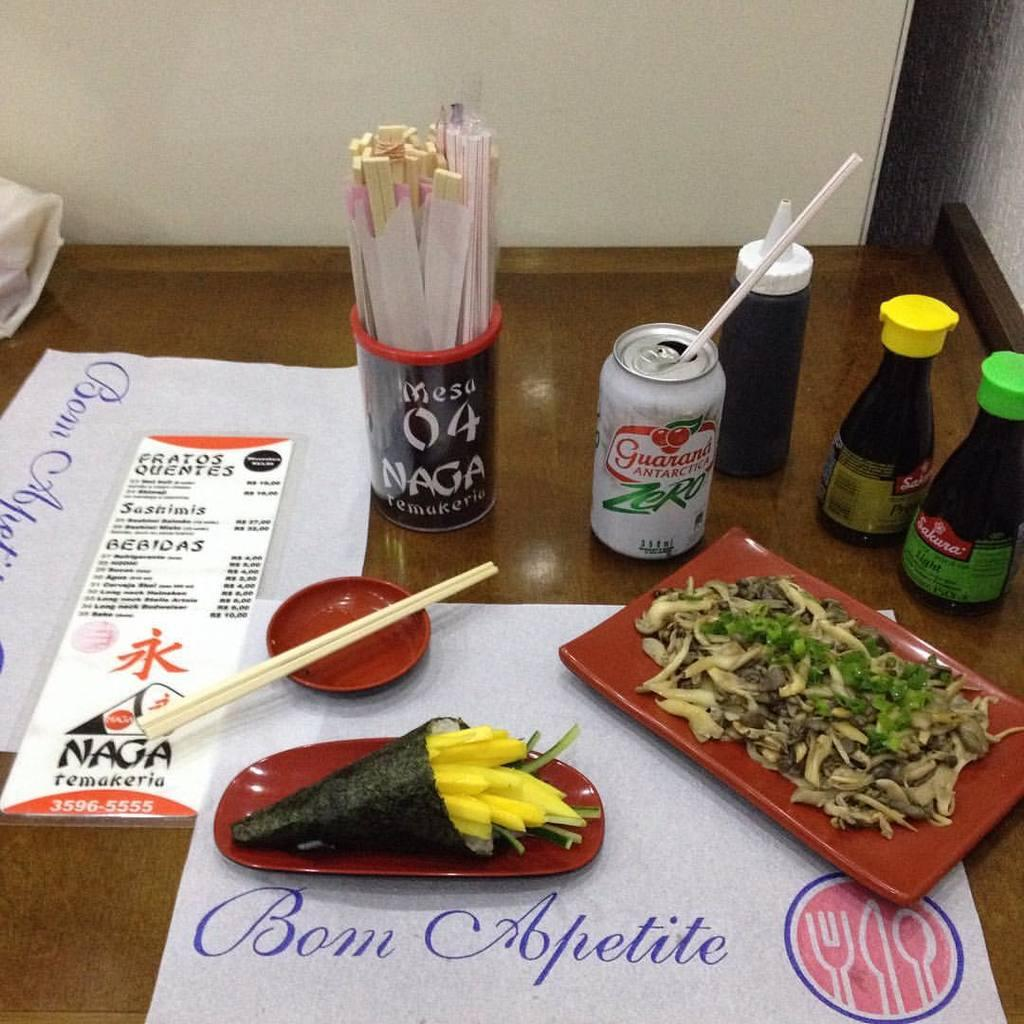What is the main piece of furniture in the image? There is a table in the image. What items can be seen on the table? Papers, food items, sticks, and bottles are on the table. How many chopsticks are present in the image? There are two chopsticks. What can be seen in the background of the image? There is a wall in the background. What type of curtain can be seen hanging from the wall in the image? There is no curtain present in the image; only a wall is visible in the background. 